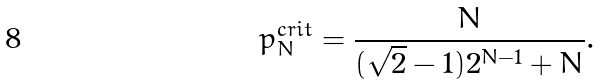Convert formula to latex. <formula><loc_0><loc_0><loc_500><loc_500>p _ { N } ^ { c r i t } = \frac { N } { ( \sqrt { 2 } - 1 ) 2 ^ { N - 1 } + N } .</formula> 